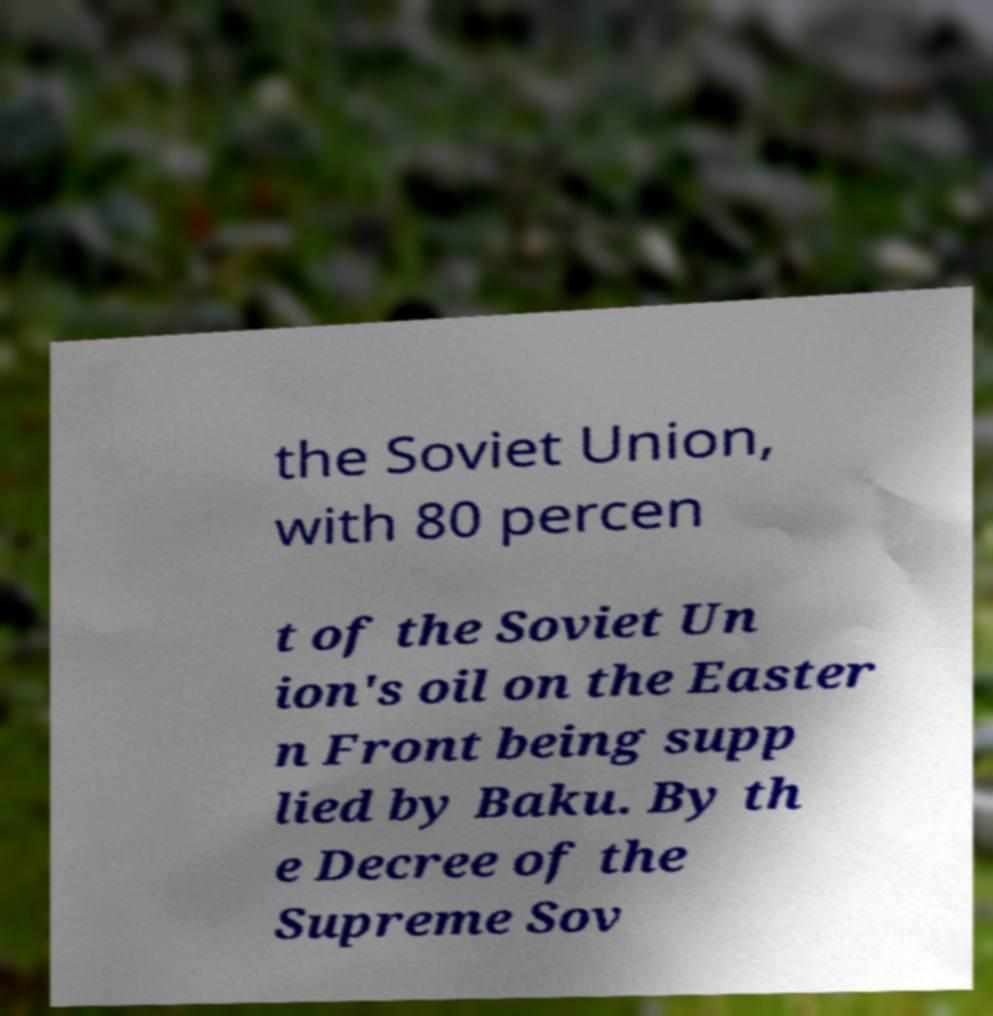I need the written content from this picture converted into text. Can you do that? the Soviet Union, with 80 percen t of the Soviet Un ion's oil on the Easter n Front being supp lied by Baku. By th e Decree of the Supreme Sov 